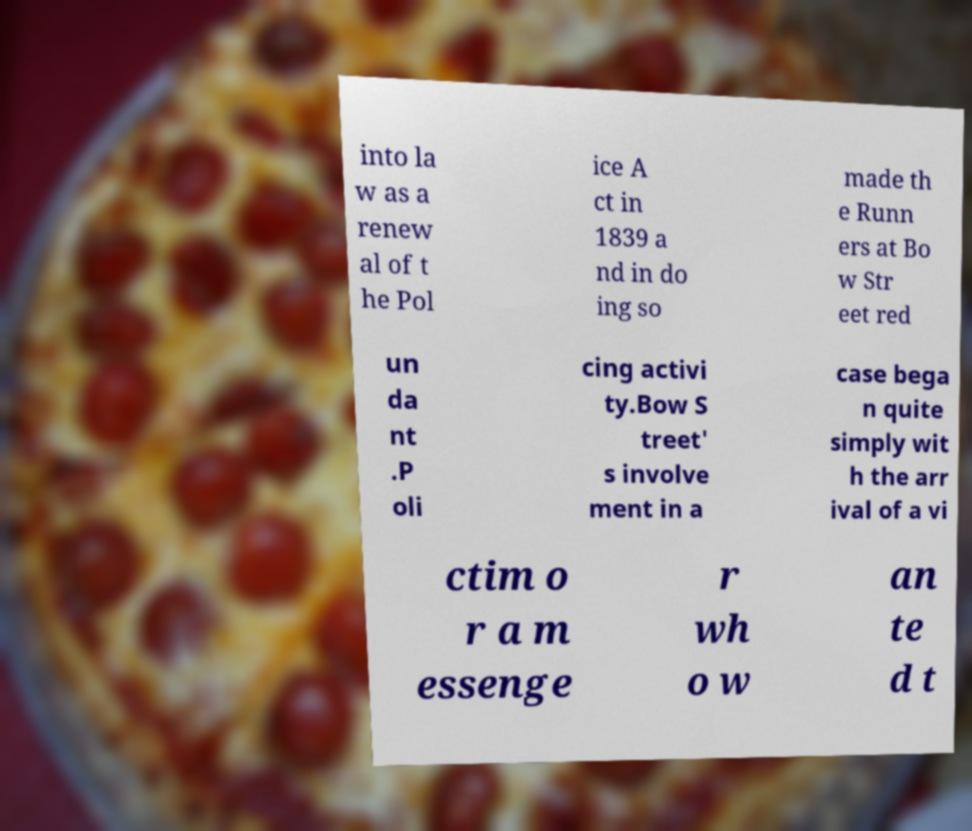There's text embedded in this image that I need extracted. Can you transcribe it verbatim? into la w as a renew al of t he Pol ice A ct in 1839 a nd in do ing so made th e Runn ers at Bo w Str eet red un da nt .P oli cing activi ty.Bow S treet' s involve ment in a case bega n quite simply wit h the arr ival of a vi ctim o r a m essenge r wh o w an te d t 